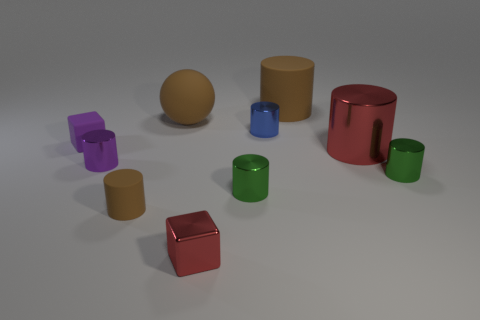Subtract 3 cylinders. How many cylinders are left? 4 Subtract all red cylinders. How many cylinders are left? 6 Subtract all tiny blue metal cylinders. How many cylinders are left? 6 Subtract all yellow cylinders. Subtract all red balls. How many cylinders are left? 7 Subtract all cubes. How many objects are left? 8 Subtract all brown things. Subtract all large green cylinders. How many objects are left? 7 Add 1 purple rubber objects. How many purple rubber objects are left? 2 Add 4 blocks. How many blocks exist? 6 Subtract 1 red cylinders. How many objects are left? 9 